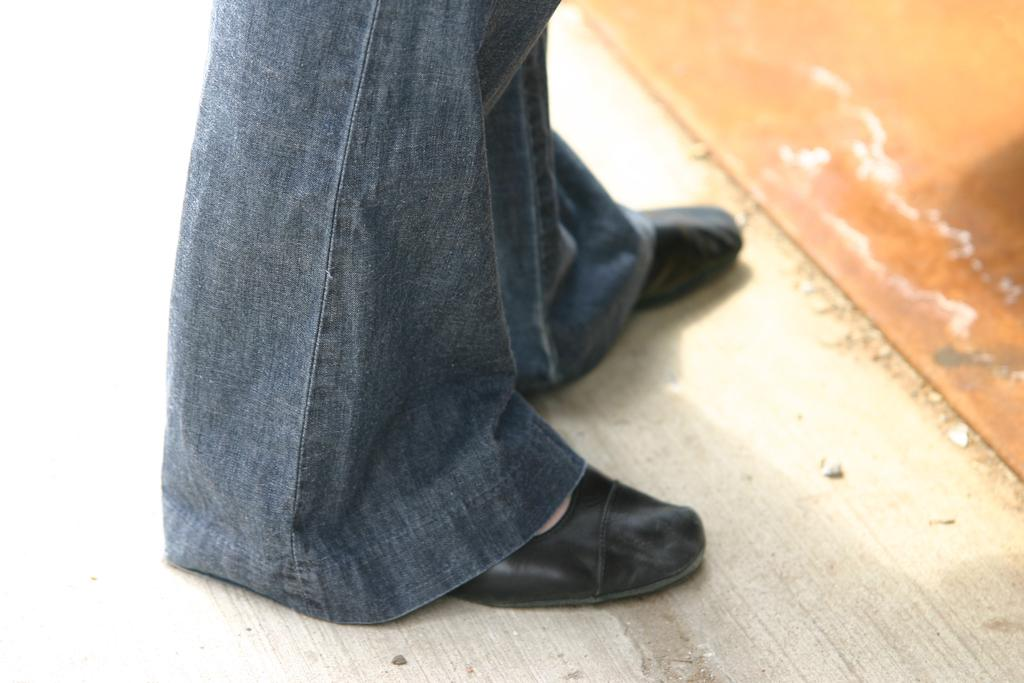What part of a person can be seen in the image? There are legs of a person in the image. What type of footwear is the person wearing? The person is wearing footwear. What material is the surface at the bottom of the image made of? There is a wooden surface at the bottom of the image. What type of root can be seen growing from the person's foot in the image? There is no root growing from the person's foot in the image. 